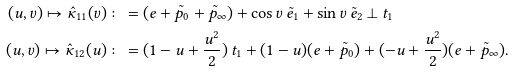Convert formula to latex. <formula><loc_0><loc_0><loc_500><loc_500>( u , v ) \mapsto \hat { \kappa } _ { 1 1 } ( v ) & \colon = ( e + \tilde { p } _ { 0 } + \tilde { p } _ { \infty } ) + \cos v \, \tilde { e } _ { 1 } + \sin v \, \tilde { e } _ { 2 } \perp t _ { 1 } \\ ( u , v ) \mapsto \hat { \kappa } _ { 1 2 } ( u ) & \colon = ( 1 - u + \frac { u ^ { 2 } } { 2 } ) \, t _ { 1 } + ( 1 - u ) ( e + \tilde { p } _ { 0 } ) + ( - u + \frac { u ^ { 2 } } { 2 } ) ( e + \tilde { p } _ { \infty } ) .</formula> 